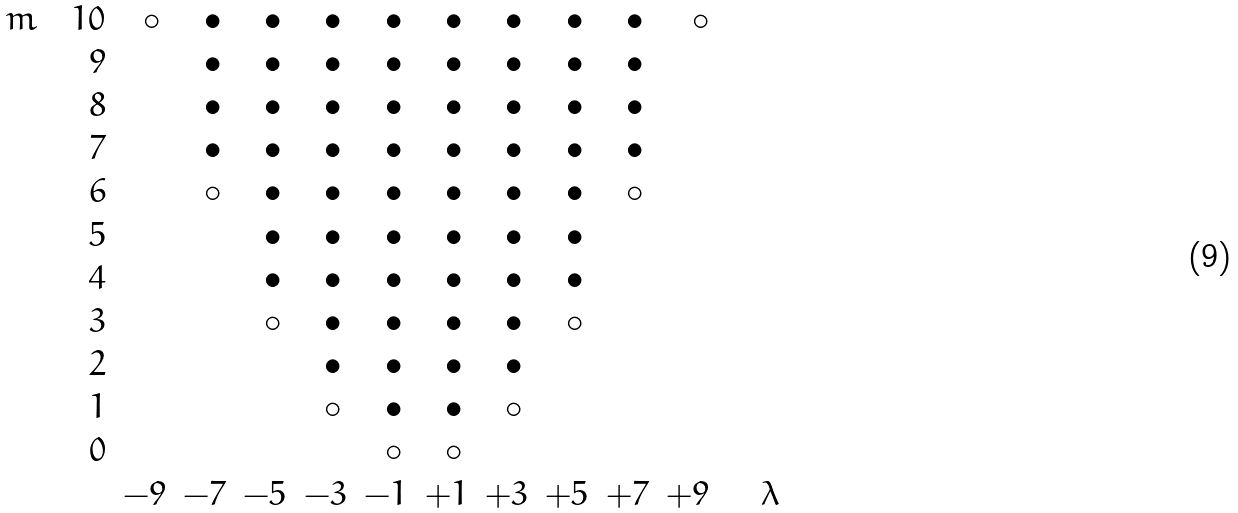Convert formula to latex. <formula><loc_0><loc_0><loc_500><loc_500>\begin{array} { r r r r r r r r r r r r } m \quad 1 0 & \circ \, & \bullet \, & \bullet \, & \bullet \, & \bullet \, & \bullet \, & \bullet \, & \bullet \, & \bullet \, & \circ \\ 9 & & \bullet \, & \bullet \, & \bullet \, & \bullet \, & \bullet \, & \bullet \, & \bullet \, & \bullet \, & \\ 8 & & \bullet \, & \bullet \, & \bullet \, & \bullet \, & \bullet \, & \bullet \, & \bullet \, & \bullet \, & \\ 7 & & \bullet \, & \bullet \, & \bullet \, & \bullet \, & \bullet \, & \bullet \, & \bullet \, & \bullet \, & \\ 6 & & \circ \, & \bullet \, & \bullet \, & \bullet \, & \bullet \, & \bullet \, & \bullet \, & \circ \, & \\ 5 & & & \bullet \, & \bullet \, & \bullet \, & \bullet \, & \bullet \, & \bullet \, & & \\ 4 & & & \bullet \, & \bullet \, & \bullet \, & \bullet \, & \bullet \, & \bullet \, & & \\ 3 & & & \circ \, & \bullet \, & \bullet \, & \bullet \, & \bullet \, & \circ \, & & \\ 2 & & & & \bullet \, & \bullet \, & \bullet \, & \bullet \, & & & \\ 1 & & & & \circ \, & \bullet \, & \bullet \, & \circ \, & & & \\ 0 & & & & & \circ \, & \circ \, & & & & \\ & - 9 & - 7 & - 5 & - 3 & - 1 & + 1 & + 3 & + 5 & + 7 & + 9 & \quad \lambda \end{array}</formula> 